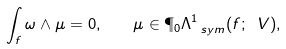<formula> <loc_0><loc_0><loc_500><loc_500>\int _ { f } \omega \wedge \mu = 0 , \quad \mu \in \P _ { 0 } \Lambda ^ { 1 } _ { \ s y m } ( f ; \ V ) ,</formula> 